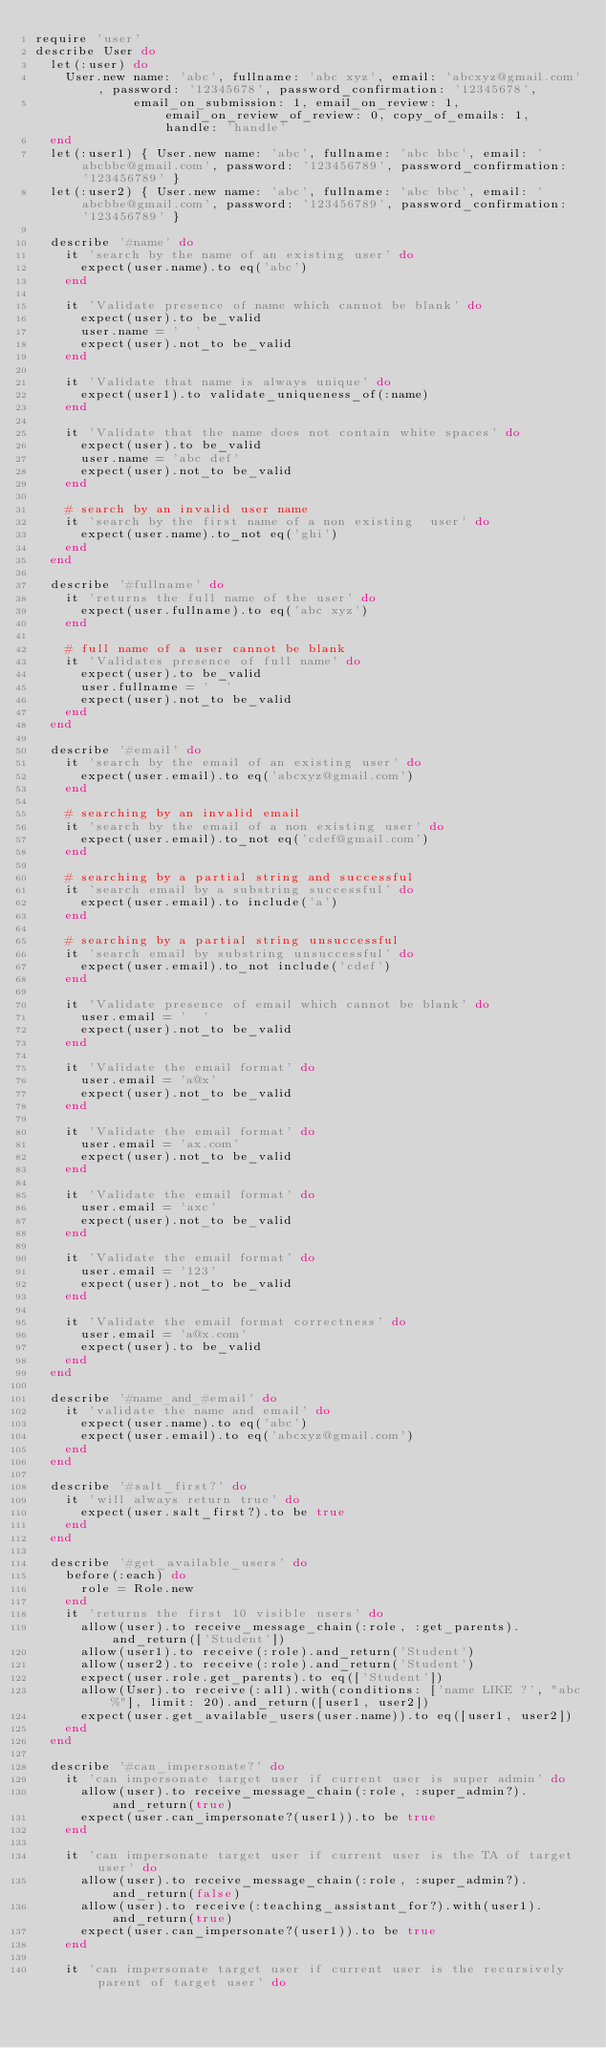Convert code to text. <code><loc_0><loc_0><loc_500><loc_500><_Ruby_>require 'user'
describe User do
  let(:user) do
    User.new name: 'abc', fullname: 'abc xyz', email: 'abcxyz@gmail.com', password: '12345678', password_confirmation: '12345678',
             email_on_submission: 1, email_on_review: 1, email_on_review_of_review: 0, copy_of_emails: 1, handle: 'handle'
  end
  let(:user1) { User.new name: 'abc', fullname: 'abc bbc', email: 'abcbbc@gmail.com', password: '123456789', password_confirmation: '123456789' }
  let(:user2) { User.new name: 'abc', fullname: 'abc bbc', email: 'abcbbe@gmail.com', password: '123456789', password_confirmation: '123456789' }

  describe '#name' do
    it 'search by the name of an existing user' do
      expect(user.name).to eq('abc')
    end

    it 'Validate presence of name which cannot be blank' do
      expect(user).to be_valid
      user.name = '  '
      expect(user).not_to be_valid
    end

    it 'Validate that name is always unique' do
      expect(user1).to validate_uniqueness_of(:name)
    end

    it 'Validate that the name does not contain white spaces' do
      expect(user).to be_valid
      user.name = 'abc def'
      expect(user).not_to be_valid
    end

    # search by an invalid user name
    it 'search by the first name of a non existing  user' do
      expect(user.name).to_not eq('ghi')
    end
  end

  describe '#fullname' do
    it 'returns the full name of the user' do
      expect(user.fullname).to eq('abc xyz')
    end

    # full name of a user cannot be blank
    it 'Validates presence of full name' do
      expect(user).to be_valid
      user.fullname = '  '
      expect(user).not_to be_valid
    end
  end

  describe '#email' do
    it 'search by the email of an existing user' do
      expect(user.email).to eq('abcxyz@gmail.com')
    end

    # searching by an invalid email
    it 'search by the email of a non existing user' do
      expect(user.email).to_not eq('cdef@gmail.com')
    end

    # searching by a partial string and successful
    it 'search email by a substring successful' do
      expect(user.email).to include('a')
    end

    # searching by a partial string unsuccessful
    it 'search email by substring unsuccessful' do
      expect(user.email).to_not include('cdef')
    end

    it 'Validate presence of email which cannot be blank' do
      user.email = '  '
      expect(user).not_to be_valid
    end

    it 'Validate the email format' do
      user.email = 'a@x'
      expect(user).not_to be_valid
    end

    it 'Validate the email format' do
      user.email = 'ax.com'
      expect(user).not_to be_valid
    end

    it 'Validate the email format' do
      user.email = 'axc'
      expect(user).not_to be_valid
    end

    it 'Validate the email format' do
      user.email = '123'
      expect(user).not_to be_valid
    end

    it 'Validate the email format correctness' do
      user.email = 'a@x.com'
      expect(user).to be_valid
    end
  end

  describe '#name_and_#email' do
    it 'validate the name and email' do
      expect(user.name).to eq('abc')
      expect(user.email).to eq('abcxyz@gmail.com')
    end
  end

  describe '#salt_first?' do
    it 'will always return true' do
      expect(user.salt_first?).to be true
    end
  end

  describe '#get_available_users' do
    before(:each) do
      role = Role.new
    end
    it 'returns the first 10 visible users' do
      allow(user).to receive_message_chain(:role, :get_parents).and_return(['Student'])
      allow(user1).to receive(:role).and_return('Student')
      allow(user2).to receive(:role).and_return('Student')
      expect(user.role.get_parents).to eq(['Student'])
      allow(User).to receive(:all).with(conditions: ['name LIKE ?', "abc%"], limit: 20).and_return([user1, user2])
      expect(user.get_available_users(user.name)).to eq([user1, user2])
    end
  end

  describe '#can_impersonate?' do
    it 'can impersonate target user if current user is super admin' do
      allow(user).to receive_message_chain(:role, :super_admin?).and_return(true)
      expect(user.can_impersonate?(user1)).to be true
    end

    it 'can impersonate target user if current user is the TA of target user' do
      allow(user).to receive_message_chain(:role, :super_admin?).and_return(false)
      allow(user).to receive(:teaching_assistant_for?).with(user1).and_return(true)
      expect(user.can_impersonate?(user1)).to be true
    end

    it 'can impersonate target user if current user is the recursively parent of target user' do</code> 